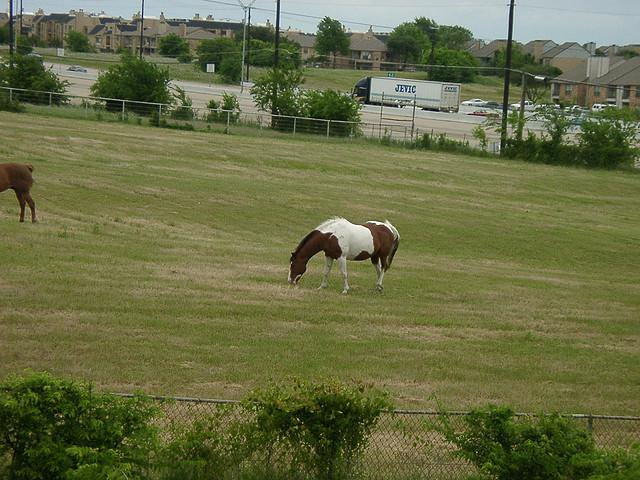What type of animals are present?

Choices:
A) deer
B) dog
C) horse
D) giraffe horse 